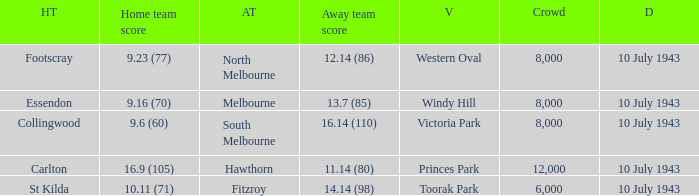When the Venue was victoria park, what was the Away team score? 16.14 (110). 